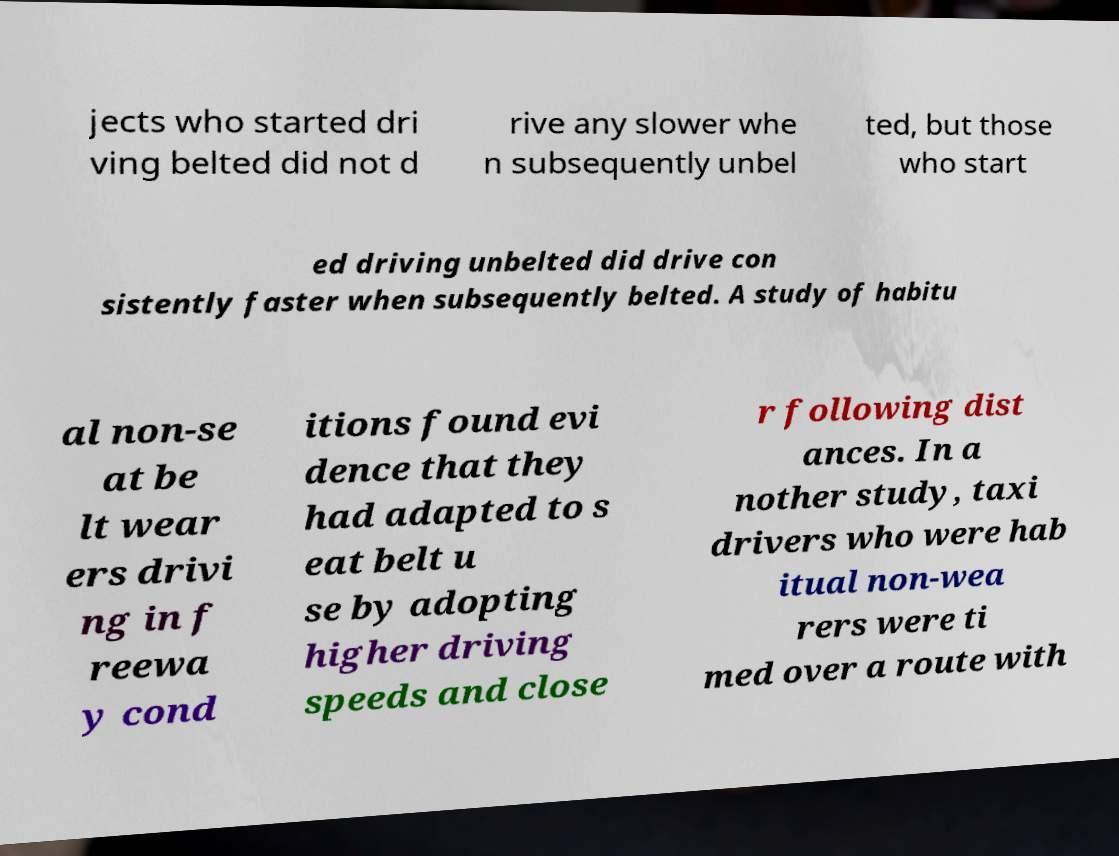What messages or text are displayed in this image? I need them in a readable, typed format. jects who started dri ving belted did not d rive any slower whe n subsequently unbel ted, but those who start ed driving unbelted did drive con sistently faster when subsequently belted. A study of habitu al non-se at be lt wear ers drivi ng in f reewa y cond itions found evi dence that they had adapted to s eat belt u se by adopting higher driving speeds and close r following dist ances. In a nother study, taxi drivers who were hab itual non-wea rers were ti med over a route with 